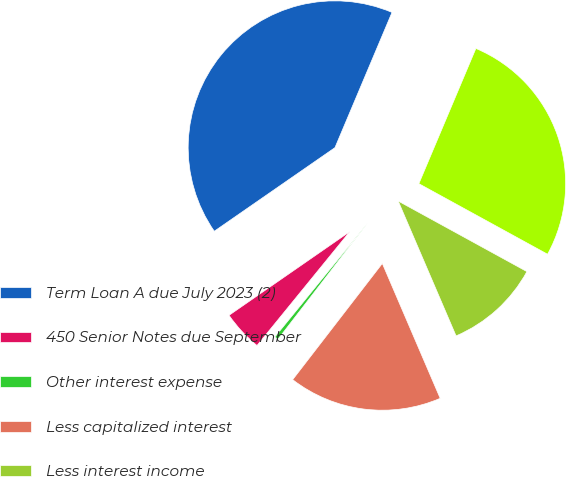Convert chart to OTSL. <chart><loc_0><loc_0><loc_500><loc_500><pie_chart><fcel>Term Loan A due July 2023 (2)<fcel>450 Senior Notes due September<fcel>Other interest expense<fcel>Less capitalized interest<fcel>Less interest income<fcel>Total<nl><fcel>41.0%<fcel>4.48%<fcel>0.42%<fcel>16.91%<fcel>10.57%<fcel>26.63%<nl></chart> 